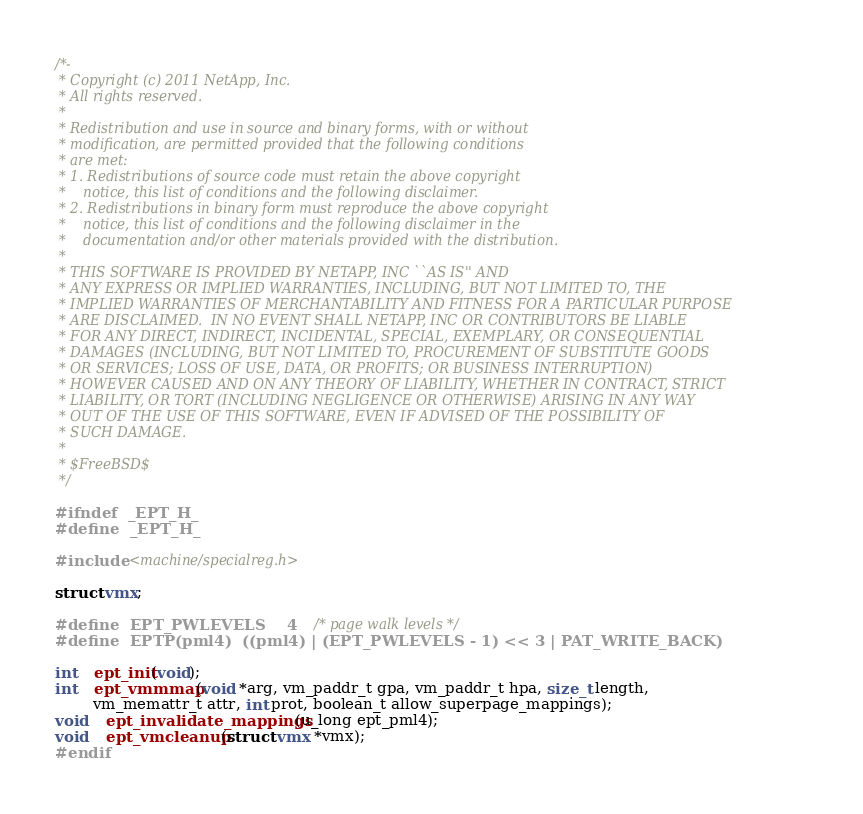Convert code to text. <code><loc_0><loc_0><loc_500><loc_500><_C_>/*-
 * Copyright (c) 2011 NetApp, Inc.
 * All rights reserved.
 *
 * Redistribution and use in source and binary forms, with or without
 * modification, are permitted provided that the following conditions
 * are met:
 * 1. Redistributions of source code must retain the above copyright
 *    notice, this list of conditions and the following disclaimer.
 * 2. Redistributions in binary form must reproduce the above copyright
 *    notice, this list of conditions and the following disclaimer in the
 *    documentation and/or other materials provided with the distribution.
 *
 * THIS SOFTWARE IS PROVIDED BY NETAPP, INC ``AS IS'' AND
 * ANY EXPRESS OR IMPLIED WARRANTIES, INCLUDING, BUT NOT LIMITED TO, THE
 * IMPLIED WARRANTIES OF MERCHANTABILITY AND FITNESS FOR A PARTICULAR PURPOSE
 * ARE DISCLAIMED.  IN NO EVENT SHALL NETAPP, INC OR CONTRIBUTORS BE LIABLE
 * FOR ANY DIRECT, INDIRECT, INCIDENTAL, SPECIAL, EXEMPLARY, OR CONSEQUENTIAL
 * DAMAGES (INCLUDING, BUT NOT LIMITED TO, PROCUREMENT OF SUBSTITUTE GOODS
 * OR SERVICES; LOSS OF USE, DATA, OR PROFITS; OR BUSINESS INTERRUPTION)
 * HOWEVER CAUSED AND ON ANY THEORY OF LIABILITY, WHETHER IN CONTRACT, STRICT
 * LIABILITY, OR TORT (INCLUDING NEGLIGENCE OR OTHERWISE) ARISING IN ANY WAY
 * OUT OF THE USE OF THIS SOFTWARE, EVEN IF ADVISED OF THE POSSIBILITY OF
 * SUCH DAMAGE.
 *
 * $FreeBSD$
 */

#ifndef	_EPT_H_
#define	_EPT_H_

#include <machine/specialreg.h>

struct vmx;

#define	EPT_PWLEVELS	4		/* page walk levels */
#define	EPTP(pml4)	((pml4) | (EPT_PWLEVELS - 1) << 3 | PAT_WRITE_BACK)

int	ept_init(void);
int	ept_vmmmap(void *arg, vm_paddr_t gpa, vm_paddr_t hpa, size_t length,
	    vm_memattr_t attr, int prot, boolean_t allow_superpage_mappings);
void	ept_invalidate_mappings(u_long ept_pml4);
void	ept_vmcleanup(struct vmx *vmx);
#endif
</code> 